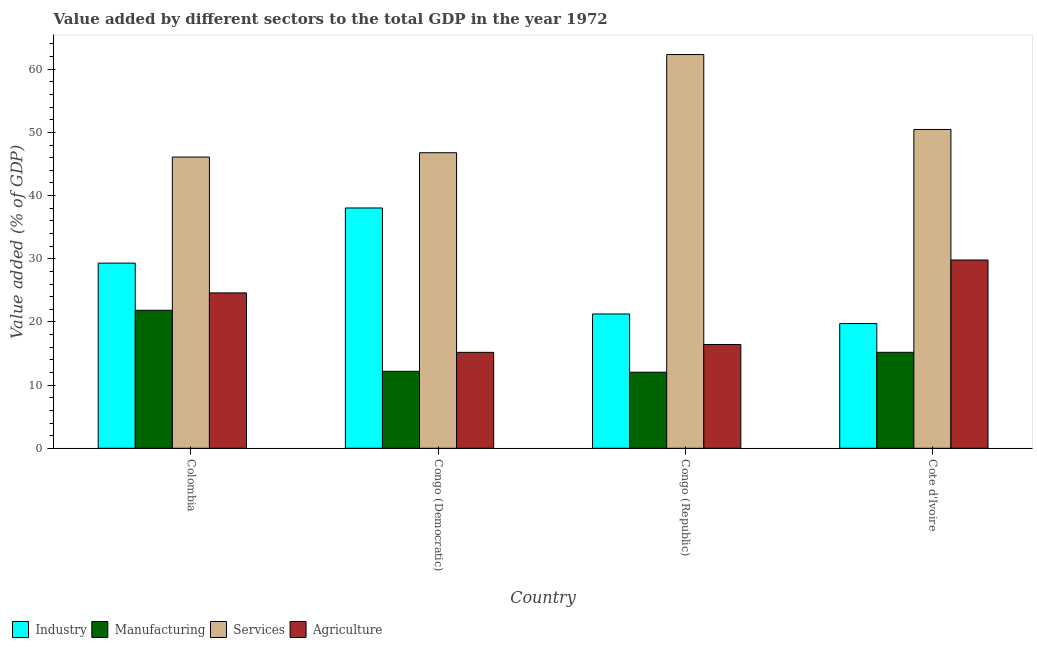How many groups of bars are there?
Provide a succinct answer. 4. Are the number of bars on each tick of the X-axis equal?
Offer a very short reply. Yes. How many bars are there on the 1st tick from the left?
Offer a very short reply. 4. What is the label of the 2nd group of bars from the left?
Give a very brief answer. Congo (Democratic). In how many cases, is the number of bars for a given country not equal to the number of legend labels?
Offer a terse response. 0. What is the value added by services sector in Colombia?
Provide a short and direct response. 46.1. Across all countries, what is the maximum value added by services sector?
Offer a terse response. 62.32. Across all countries, what is the minimum value added by manufacturing sector?
Your answer should be compact. 12.04. In which country was the value added by manufacturing sector maximum?
Ensure brevity in your answer.  Colombia. In which country was the value added by industrial sector minimum?
Your answer should be very brief. Cote d'Ivoire. What is the total value added by services sector in the graph?
Your answer should be compact. 205.66. What is the difference between the value added by industrial sector in Colombia and that in Congo (Democratic)?
Ensure brevity in your answer.  -8.73. What is the difference between the value added by manufacturing sector in Congo (Democratic) and the value added by agricultural sector in Colombia?
Your answer should be very brief. -12.41. What is the average value added by agricultural sector per country?
Offer a very short reply. 21.5. What is the difference between the value added by manufacturing sector and value added by services sector in Colombia?
Keep it short and to the point. -24.26. In how many countries, is the value added by services sector greater than 40 %?
Offer a terse response. 4. What is the ratio of the value added by manufacturing sector in Colombia to that in Congo (Democratic)?
Offer a very short reply. 1.79. Is the value added by manufacturing sector in Congo (Democratic) less than that in Congo (Republic)?
Offer a terse response. No. Is the difference between the value added by industrial sector in Congo (Democratic) and Congo (Republic) greater than the difference between the value added by services sector in Congo (Democratic) and Congo (Republic)?
Make the answer very short. Yes. What is the difference between the highest and the second highest value added by agricultural sector?
Make the answer very short. 5.21. What is the difference between the highest and the lowest value added by manufacturing sector?
Ensure brevity in your answer.  9.8. In how many countries, is the value added by manufacturing sector greater than the average value added by manufacturing sector taken over all countries?
Make the answer very short. 1. Is it the case that in every country, the sum of the value added by industrial sector and value added by services sector is greater than the sum of value added by manufacturing sector and value added by agricultural sector?
Provide a succinct answer. No. What does the 4th bar from the left in Colombia represents?
Your response must be concise. Agriculture. What does the 2nd bar from the right in Congo (Republic) represents?
Ensure brevity in your answer.  Services. Is it the case that in every country, the sum of the value added by industrial sector and value added by manufacturing sector is greater than the value added by services sector?
Keep it short and to the point. No. How many bars are there?
Make the answer very short. 16. How many countries are there in the graph?
Your answer should be compact. 4. Are the values on the major ticks of Y-axis written in scientific E-notation?
Your answer should be compact. No. Does the graph contain any zero values?
Provide a short and direct response. No. How many legend labels are there?
Your answer should be very brief. 4. How are the legend labels stacked?
Offer a very short reply. Horizontal. What is the title of the graph?
Make the answer very short. Value added by different sectors to the total GDP in the year 1972. Does "Permission" appear as one of the legend labels in the graph?
Keep it short and to the point. No. What is the label or title of the X-axis?
Give a very brief answer. Country. What is the label or title of the Y-axis?
Give a very brief answer. Value added (% of GDP). What is the Value added (% of GDP) in Industry in Colombia?
Ensure brevity in your answer.  29.31. What is the Value added (% of GDP) in Manufacturing in Colombia?
Your answer should be very brief. 21.84. What is the Value added (% of GDP) in Services in Colombia?
Your response must be concise. 46.1. What is the Value added (% of GDP) of Agriculture in Colombia?
Give a very brief answer. 24.59. What is the Value added (% of GDP) of Industry in Congo (Democratic)?
Your response must be concise. 38.04. What is the Value added (% of GDP) in Manufacturing in Congo (Democratic)?
Your answer should be compact. 12.18. What is the Value added (% of GDP) in Services in Congo (Democratic)?
Your answer should be very brief. 46.78. What is the Value added (% of GDP) in Agriculture in Congo (Democratic)?
Provide a succinct answer. 15.18. What is the Value added (% of GDP) in Industry in Congo (Republic)?
Your answer should be very brief. 21.26. What is the Value added (% of GDP) in Manufacturing in Congo (Republic)?
Offer a terse response. 12.04. What is the Value added (% of GDP) of Services in Congo (Republic)?
Your answer should be compact. 62.32. What is the Value added (% of GDP) in Agriculture in Congo (Republic)?
Make the answer very short. 16.43. What is the Value added (% of GDP) of Industry in Cote d'Ivoire?
Ensure brevity in your answer.  19.74. What is the Value added (% of GDP) of Manufacturing in Cote d'Ivoire?
Offer a terse response. 15.19. What is the Value added (% of GDP) of Services in Cote d'Ivoire?
Your answer should be very brief. 50.46. What is the Value added (% of GDP) of Agriculture in Cote d'Ivoire?
Provide a short and direct response. 29.8. Across all countries, what is the maximum Value added (% of GDP) in Industry?
Offer a very short reply. 38.04. Across all countries, what is the maximum Value added (% of GDP) of Manufacturing?
Provide a short and direct response. 21.84. Across all countries, what is the maximum Value added (% of GDP) in Services?
Ensure brevity in your answer.  62.32. Across all countries, what is the maximum Value added (% of GDP) in Agriculture?
Provide a succinct answer. 29.8. Across all countries, what is the minimum Value added (% of GDP) in Industry?
Offer a terse response. 19.74. Across all countries, what is the minimum Value added (% of GDP) in Manufacturing?
Offer a very short reply. 12.04. Across all countries, what is the minimum Value added (% of GDP) of Services?
Offer a very short reply. 46.1. Across all countries, what is the minimum Value added (% of GDP) in Agriculture?
Offer a terse response. 15.18. What is the total Value added (% of GDP) in Industry in the graph?
Make the answer very short. 108.34. What is the total Value added (% of GDP) of Manufacturing in the graph?
Your answer should be compact. 61.25. What is the total Value added (% of GDP) of Services in the graph?
Make the answer very short. 205.66. What is the total Value added (% of GDP) of Agriculture in the graph?
Offer a terse response. 86. What is the difference between the Value added (% of GDP) of Industry in Colombia and that in Congo (Democratic)?
Make the answer very short. -8.73. What is the difference between the Value added (% of GDP) of Manufacturing in Colombia and that in Congo (Democratic)?
Give a very brief answer. 9.66. What is the difference between the Value added (% of GDP) of Services in Colombia and that in Congo (Democratic)?
Your answer should be very brief. -0.68. What is the difference between the Value added (% of GDP) of Agriculture in Colombia and that in Congo (Democratic)?
Provide a short and direct response. 9.41. What is the difference between the Value added (% of GDP) in Industry in Colombia and that in Congo (Republic)?
Offer a very short reply. 8.05. What is the difference between the Value added (% of GDP) of Manufacturing in Colombia and that in Congo (Republic)?
Offer a terse response. 9.8. What is the difference between the Value added (% of GDP) in Services in Colombia and that in Congo (Republic)?
Provide a succinct answer. -16.22. What is the difference between the Value added (% of GDP) in Agriculture in Colombia and that in Congo (Republic)?
Your response must be concise. 8.17. What is the difference between the Value added (% of GDP) in Industry in Colombia and that in Cote d'Ivoire?
Provide a short and direct response. 9.57. What is the difference between the Value added (% of GDP) in Manufacturing in Colombia and that in Cote d'Ivoire?
Keep it short and to the point. 6.65. What is the difference between the Value added (% of GDP) of Services in Colombia and that in Cote d'Ivoire?
Provide a succinct answer. -4.36. What is the difference between the Value added (% of GDP) in Agriculture in Colombia and that in Cote d'Ivoire?
Your answer should be very brief. -5.21. What is the difference between the Value added (% of GDP) of Industry in Congo (Democratic) and that in Congo (Republic)?
Provide a short and direct response. 16.78. What is the difference between the Value added (% of GDP) of Manufacturing in Congo (Democratic) and that in Congo (Republic)?
Give a very brief answer. 0.14. What is the difference between the Value added (% of GDP) in Services in Congo (Democratic) and that in Congo (Republic)?
Offer a terse response. -15.54. What is the difference between the Value added (% of GDP) in Agriculture in Congo (Democratic) and that in Congo (Republic)?
Offer a terse response. -1.24. What is the difference between the Value added (% of GDP) of Industry in Congo (Democratic) and that in Cote d'Ivoire?
Offer a very short reply. 18.3. What is the difference between the Value added (% of GDP) of Manufacturing in Congo (Democratic) and that in Cote d'Ivoire?
Your response must be concise. -3.01. What is the difference between the Value added (% of GDP) in Services in Congo (Democratic) and that in Cote d'Ivoire?
Ensure brevity in your answer.  -3.68. What is the difference between the Value added (% of GDP) in Agriculture in Congo (Democratic) and that in Cote d'Ivoire?
Give a very brief answer. -14.62. What is the difference between the Value added (% of GDP) in Industry in Congo (Republic) and that in Cote d'Ivoire?
Give a very brief answer. 1.52. What is the difference between the Value added (% of GDP) of Manufacturing in Congo (Republic) and that in Cote d'Ivoire?
Provide a succinct answer. -3.15. What is the difference between the Value added (% of GDP) of Services in Congo (Republic) and that in Cote d'Ivoire?
Offer a very short reply. 11.86. What is the difference between the Value added (% of GDP) in Agriculture in Congo (Republic) and that in Cote d'Ivoire?
Your answer should be compact. -13.38. What is the difference between the Value added (% of GDP) of Industry in Colombia and the Value added (% of GDP) of Manufacturing in Congo (Democratic)?
Ensure brevity in your answer.  17.13. What is the difference between the Value added (% of GDP) of Industry in Colombia and the Value added (% of GDP) of Services in Congo (Democratic)?
Give a very brief answer. -17.47. What is the difference between the Value added (% of GDP) of Industry in Colombia and the Value added (% of GDP) of Agriculture in Congo (Democratic)?
Make the answer very short. 14.13. What is the difference between the Value added (% of GDP) of Manufacturing in Colombia and the Value added (% of GDP) of Services in Congo (Democratic)?
Provide a short and direct response. -24.94. What is the difference between the Value added (% of GDP) of Manufacturing in Colombia and the Value added (% of GDP) of Agriculture in Congo (Democratic)?
Give a very brief answer. 6.66. What is the difference between the Value added (% of GDP) in Services in Colombia and the Value added (% of GDP) in Agriculture in Congo (Democratic)?
Offer a very short reply. 30.92. What is the difference between the Value added (% of GDP) of Industry in Colombia and the Value added (% of GDP) of Manufacturing in Congo (Republic)?
Keep it short and to the point. 17.27. What is the difference between the Value added (% of GDP) in Industry in Colombia and the Value added (% of GDP) in Services in Congo (Republic)?
Keep it short and to the point. -33.01. What is the difference between the Value added (% of GDP) of Industry in Colombia and the Value added (% of GDP) of Agriculture in Congo (Republic)?
Keep it short and to the point. 12.88. What is the difference between the Value added (% of GDP) in Manufacturing in Colombia and the Value added (% of GDP) in Services in Congo (Republic)?
Provide a short and direct response. -40.48. What is the difference between the Value added (% of GDP) of Manufacturing in Colombia and the Value added (% of GDP) of Agriculture in Congo (Republic)?
Your answer should be compact. 5.42. What is the difference between the Value added (% of GDP) in Services in Colombia and the Value added (% of GDP) in Agriculture in Congo (Republic)?
Your answer should be very brief. 29.67. What is the difference between the Value added (% of GDP) in Industry in Colombia and the Value added (% of GDP) in Manufacturing in Cote d'Ivoire?
Your response must be concise. 14.12. What is the difference between the Value added (% of GDP) in Industry in Colombia and the Value added (% of GDP) in Services in Cote d'Ivoire?
Make the answer very short. -21.15. What is the difference between the Value added (% of GDP) of Industry in Colombia and the Value added (% of GDP) of Agriculture in Cote d'Ivoire?
Provide a short and direct response. -0.49. What is the difference between the Value added (% of GDP) of Manufacturing in Colombia and the Value added (% of GDP) of Services in Cote d'Ivoire?
Provide a succinct answer. -28.62. What is the difference between the Value added (% of GDP) in Manufacturing in Colombia and the Value added (% of GDP) in Agriculture in Cote d'Ivoire?
Offer a terse response. -7.96. What is the difference between the Value added (% of GDP) in Services in Colombia and the Value added (% of GDP) in Agriculture in Cote d'Ivoire?
Offer a terse response. 16.3. What is the difference between the Value added (% of GDP) in Industry in Congo (Democratic) and the Value added (% of GDP) in Manufacturing in Congo (Republic)?
Offer a very short reply. 26. What is the difference between the Value added (% of GDP) in Industry in Congo (Democratic) and the Value added (% of GDP) in Services in Congo (Republic)?
Ensure brevity in your answer.  -24.28. What is the difference between the Value added (% of GDP) in Industry in Congo (Democratic) and the Value added (% of GDP) in Agriculture in Congo (Republic)?
Your answer should be compact. 21.61. What is the difference between the Value added (% of GDP) of Manufacturing in Congo (Democratic) and the Value added (% of GDP) of Services in Congo (Republic)?
Give a very brief answer. -50.14. What is the difference between the Value added (% of GDP) of Manufacturing in Congo (Democratic) and the Value added (% of GDP) of Agriculture in Congo (Republic)?
Make the answer very short. -4.24. What is the difference between the Value added (% of GDP) of Services in Congo (Democratic) and the Value added (% of GDP) of Agriculture in Congo (Republic)?
Offer a terse response. 30.36. What is the difference between the Value added (% of GDP) of Industry in Congo (Democratic) and the Value added (% of GDP) of Manufacturing in Cote d'Ivoire?
Your answer should be very brief. 22.85. What is the difference between the Value added (% of GDP) in Industry in Congo (Democratic) and the Value added (% of GDP) in Services in Cote d'Ivoire?
Make the answer very short. -12.43. What is the difference between the Value added (% of GDP) in Industry in Congo (Democratic) and the Value added (% of GDP) in Agriculture in Cote d'Ivoire?
Offer a very short reply. 8.24. What is the difference between the Value added (% of GDP) of Manufacturing in Congo (Democratic) and the Value added (% of GDP) of Services in Cote d'Ivoire?
Your answer should be compact. -38.28. What is the difference between the Value added (% of GDP) of Manufacturing in Congo (Democratic) and the Value added (% of GDP) of Agriculture in Cote d'Ivoire?
Ensure brevity in your answer.  -17.62. What is the difference between the Value added (% of GDP) in Services in Congo (Democratic) and the Value added (% of GDP) in Agriculture in Cote d'Ivoire?
Provide a short and direct response. 16.98. What is the difference between the Value added (% of GDP) in Industry in Congo (Republic) and the Value added (% of GDP) in Manufacturing in Cote d'Ivoire?
Your response must be concise. 6.07. What is the difference between the Value added (% of GDP) of Industry in Congo (Republic) and the Value added (% of GDP) of Services in Cote d'Ivoire?
Your answer should be compact. -29.21. What is the difference between the Value added (% of GDP) of Industry in Congo (Republic) and the Value added (% of GDP) of Agriculture in Cote d'Ivoire?
Your answer should be very brief. -8.54. What is the difference between the Value added (% of GDP) in Manufacturing in Congo (Republic) and the Value added (% of GDP) in Services in Cote d'Ivoire?
Your answer should be very brief. -38.42. What is the difference between the Value added (% of GDP) of Manufacturing in Congo (Republic) and the Value added (% of GDP) of Agriculture in Cote d'Ivoire?
Provide a succinct answer. -17.76. What is the difference between the Value added (% of GDP) of Services in Congo (Republic) and the Value added (% of GDP) of Agriculture in Cote d'Ivoire?
Offer a very short reply. 32.52. What is the average Value added (% of GDP) in Industry per country?
Offer a very short reply. 27.08. What is the average Value added (% of GDP) in Manufacturing per country?
Provide a succinct answer. 15.31. What is the average Value added (% of GDP) in Services per country?
Your answer should be very brief. 51.41. What is the average Value added (% of GDP) of Agriculture per country?
Provide a succinct answer. 21.5. What is the difference between the Value added (% of GDP) in Industry and Value added (% of GDP) in Manufacturing in Colombia?
Provide a short and direct response. 7.47. What is the difference between the Value added (% of GDP) of Industry and Value added (% of GDP) of Services in Colombia?
Make the answer very short. -16.79. What is the difference between the Value added (% of GDP) in Industry and Value added (% of GDP) in Agriculture in Colombia?
Your response must be concise. 4.72. What is the difference between the Value added (% of GDP) of Manufacturing and Value added (% of GDP) of Services in Colombia?
Your answer should be very brief. -24.26. What is the difference between the Value added (% of GDP) in Manufacturing and Value added (% of GDP) in Agriculture in Colombia?
Offer a terse response. -2.75. What is the difference between the Value added (% of GDP) of Services and Value added (% of GDP) of Agriculture in Colombia?
Your answer should be compact. 21.51. What is the difference between the Value added (% of GDP) of Industry and Value added (% of GDP) of Manufacturing in Congo (Democratic)?
Make the answer very short. 25.85. What is the difference between the Value added (% of GDP) in Industry and Value added (% of GDP) in Services in Congo (Democratic)?
Provide a short and direct response. -8.74. What is the difference between the Value added (% of GDP) of Industry and Value added (% of GDP) of Agriculture in Congo (Democratic)?
Ensure brevity in your answer.  22.85. What is the difference between the Value added (% of GDP) in Manufacturing and Value added (% of GDP) in Services in Congo (Democratic)?
Make the answer very short. -34.6. What is the difference between the Value added (% of GDP) of Manufacturing and Value added (% of GDP) of Agriculture in Congo (Democratic)?
Provide a short and direct response. -3. What is the difference between the Value added (% of GDP) of Services and Value added (% of GDP) of Agriculture in Congo (Democratic)?
Offer a terse response. 31.6. What is the difference between the Value added (% of GDP) of Industry and Value added (% of GDP) of Manufacturing in Congo (Republic)?
Keep it short and to the point. 9.22. What is the difference between the Value added (% of GDP) in Industry and Value added (% of GDP) in Services in Congo (Republic)?
Give a very brief answer. -41.06. What is the difference between the Value added (% of GDP) of Industry and Value added (% of GDP) of Agriculture in Congo (Republic)?
Offer a very short reply. 4.83. What is the difference between the Value added (% of GDP) in Manufacturing and Value added (% of GDP) in Services in Congo (Republic)?
Your answer should be compact. -50.28. What is the difference between the Value added (% of GDP) of Manufacturing and Value added (% of GDP) of Agriculture in Congo (Republic)?
Your answer should be compact. -4.38. What is the difference between the Value added (% of GDP) of Services and Value added (% of GDP) of Agriculture in Congo (Republic)?
Your answer should be compact. 45.89. What is the difference between the Value added (% of GDP) in Industry and Value added (% of GDP) in Manufacturing in Cote d'Ivoire?
Keep it short and to the point. 4.55. What is the difference between the Value added (% of GDP) in Industry and Value added (% of GDP) in Services in Cote d'Ivoire?
Keep it short and to the point. -30.72. What is the difference between the Value added (% of GDP) in Industry and Value added (% of GDP) in Agriculture in Cote d'Ivoire?
Provide a short and direct response. -10.06. What is the difference between the Value added (% of GDP) of Manufacturing and Value added (% of GDP) of Services in Cote d'Ivoire?
Your answer should be compact. -35.27. What is the difference between the Value added (% of GDP) in Manufacturing and Value added (% of GDP) in Agriculture in Cote d'Ivoire?
Your answer should be compact. -14.61. What is the difference between the Value added (% of GDP) in Services and Value added (% of GDP) in Agriculture in Cote d'Ivoire?
Ensure brevity in your answer.  20.66. What is the ratio of the Value added (% of GDP) in Industry in Colombia to that in Congo (Democratic)?
Provide a succinct answer. 0.77. What is the ratio of the Value added (% of GDP) of Manufacturing in Colombia to that in Congo (Democratic)?
Ensure brevity in your answer.  1.79. What is the ratio of the Value added (% of GDP) in Services in Colombia to that in Congo (Democratic)?
Your answer should be compact. 0.99. What is the ratio of the Value added (% of GDP) in Agriculture in Colombia to that in Congo (Democratic)?
Your answer should be very brief. 1.62. What is the ratio of the Value added (% of GDP) in Industry in Colombia to that in Congo (Republic)?
Your response must be concise. 1.38. What is the ratio of the Value added (% of GDP) of Manufacturing in Colombia to that in Congo (Republic)?
Your answer should be very brief. 1.81. What is the ratio of the Value added (% of GDP) in Services in Colombia to that in Congo (Republic)?
Give a very brief answer. 0.74. What is the ratio of the Value added (% of GDP) in Agriculture in Colombia to that in Congo (Republic)?
Make the answer very short. 1.5. What is the ratio of the Value added (% of GDP) in Industry in Colombia to that in Cote d'Ivoire?
Give a very brief answer. 1.48. What is the ratio of the Value added (% of GDP) in Manufacturing in Colombia to that in Cote d'Ivoire?
Make the answer very short. 1.44. What is the ratio of the Value added (% of GDP) of Services in Colombia to that in Cote d'Ivoire?
Your answer should be very brief. 0.91. What is the ratio of the Value added (% of GDP) in Agriculture in Colombia to that in Cote d'Ivoire?
Give a very brief answer. 0.83. What is the ratio of the Value added (% of GDP) of Industry in Congo (Democratic) to that in Congo (Republic)?
Offer a terse response. 1.79. What is the ratio of the Value added (% of GDP) of Manufacturing in Congo (Democratic) to that in Congo (Republic)?
Your answer should be compact. 1.01. What is the ratio of the Value added (% of GDP) of Services in Congo (Democratic) to that in Congo (Republic)?
Your response must be concise. 0.75. What is the ratio of the Value added (% of GDP) in Agriculture in Congo (Democratic) to that in Congo (Republic)?
Keep it short and to the point. 0.92. What is the ratio of the Value added (% of GDP) in Industry in Congo (Democratic) to that in Cote d'Ivoire?
Give a very brief answer. 1.93. What is the ratio of the Value added (% of GDP) of Manufacturing in Congo (Democratic) to that in Cote d'Ivoire?
Your response must be concise. 0.8. What is the ratio of the Value added (% of GDP) in Services in Congo (Democratic) to that in Cote d'Ivoire?
Make the answer very short. 0.93. What is the ratio of the Value added (% of GDP) in Agriculture in Congo (Democratic) to that in Cote d'Ivoire?
Keep it short and to the point. 0.51. What is the ratio of the Value added (% of GDP) in Industry in Congo (Republic) to that in Cote d'Ivoire?
Your response must be concise. 1.08. What is the ratio of the Value added (% of GDP) in Manufacturing in Congo (Republic) to that in Cote d'Ivoire?
Keep it short and to the point. 0.79. What is the ratio of the Value added (% of GDP) of Services in Congo (Republic) to that in Cote d'Ivoire?
Offer a terse response. 1.24. What is the ratio of the Value added (% of GDP) of Agriculture in Congo (Republic) to that in Cote d'Ivoire?
Your answer should be compact. 0.55. What is the difference between the highest and the second highest Value added (% of GDP) in Industry?
Your answer should be very brief. 8.73. What is the difference between the highest and the second highest Value added (% of GDP) of Manufacturing?
Provide a short and direct response. 6.65. What is the difference between the highest and the second highest Value added (% of GDP) in Services?
Your response must be concise. 11.86. What is the difference between the highest and the second highest Value added (% of GDP) of Agriculture?
Your response must be concise. 5.21. What is the difference between the highest and the lowest Value added (% of GDP) in Industry?
Keep it short and to the point. 18.3. What is the difference between the highest and the lowest Value added (% of GDP) of Manufacturing?
Your response must be concise. 9.8. What is the difference between the highest and the lowest Value added (% of GDP) in Services?
Your answer should be compact. 16.22. What is the difference between the highest and the lowest Value added (% of GDP) in Agriculture?
Provide a succinct answer. 14.62. 